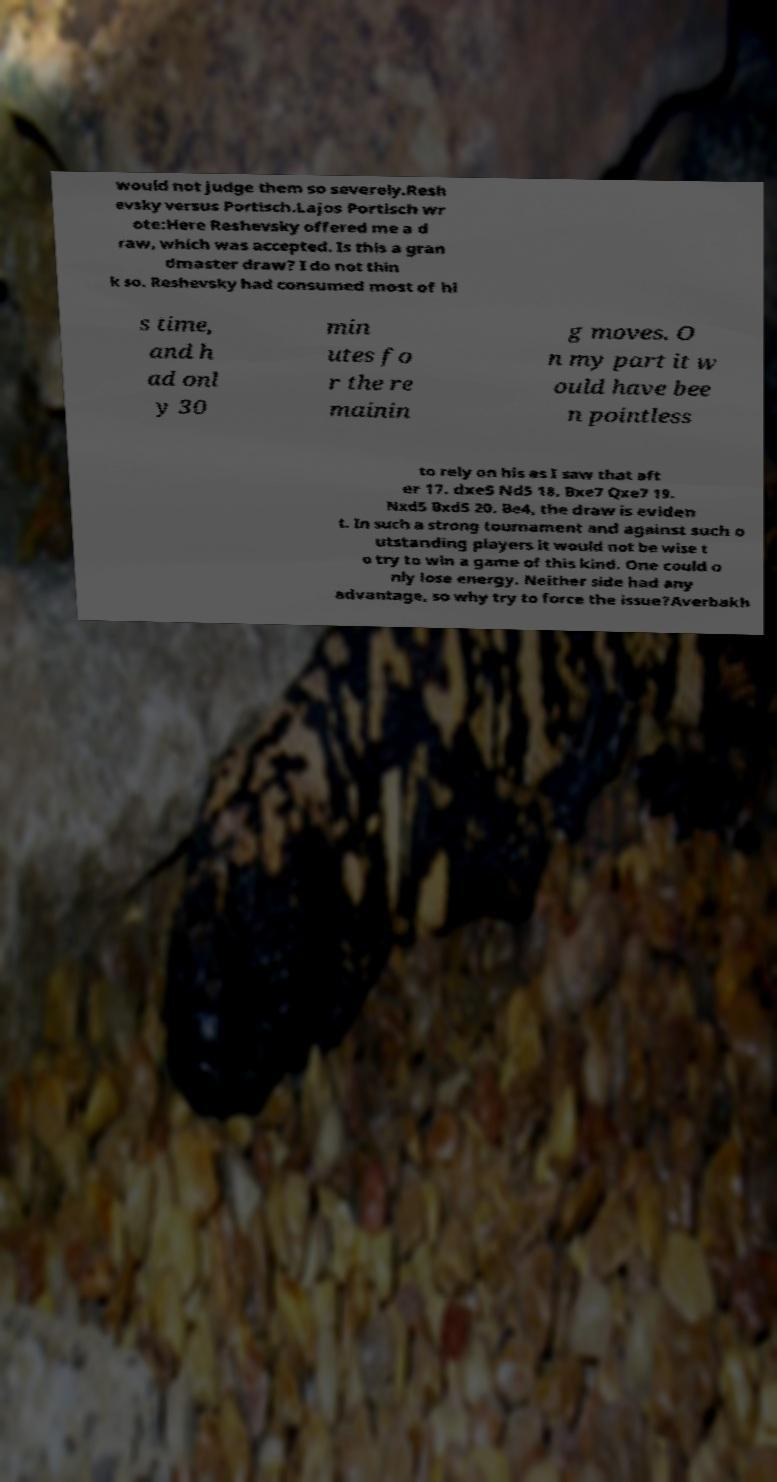Please identify and transcribe the text found in this image. would not judge them so severely.Resh evsky versus Portisch.Lajos Portisch wr ote:Here Reshevsky offered me a d raw, which was accepted. Is this a gran dmaster draw? I do not thin k so. Reshevsky had consumed most of hi s time, and h ad onl y 30 min utes fo r the re mainin g moves. O n my part it w ould have bee n pointless to rely on his as I saw that aft er 17. dxe5 Nd5 18. Bxe7 Qxe7 19. Nxd5 Bxd5 20. Be4, the draw is eviden t. In such a strong tournament and against such o utstanding players it would not be wise t o try to win a game of this kind. One could o nly lose energy. Neither side had any advantage, so why try to force the issue?Averbakh 